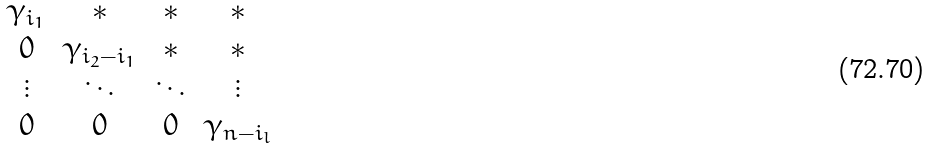Convert formula to latex. <formula><loc_0><loc_0><loc_500><loc_500>\begin{matrix} \gamma _ { i _ { 1 } } & * & * & * \\ 0 & \gamma _ { i _ { 2 } - i _ { 1 } } & * & * \\ \vdots & \ddots & \ddots & \vdots \\ 0 & 0 & 0 & \gamma _ { n - i _ { l } } \end{matrix}</formula> 